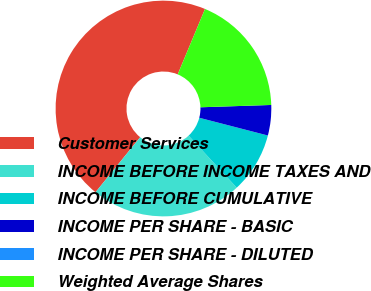Convert chart to OTSL. <chart><loc_0><loc_0><loc_500><loc_500><pie_chart><fcel>Customer Services<fcel>INCOME BEFORE INCOME TAXES AND<fcel>INCOME BEFORE CUMULATIVE<fcel>INCOME PER SHARE - BASIC<fcel>INCOME PER SHARE - DILUTED<fcel>Weighted Average Shares<nl><fcel>45.45%<fcel>22.73%<fcel>9.09%<fcel>4.55%<fcel>0.0%<fcel>18.18%<nl></chart> 